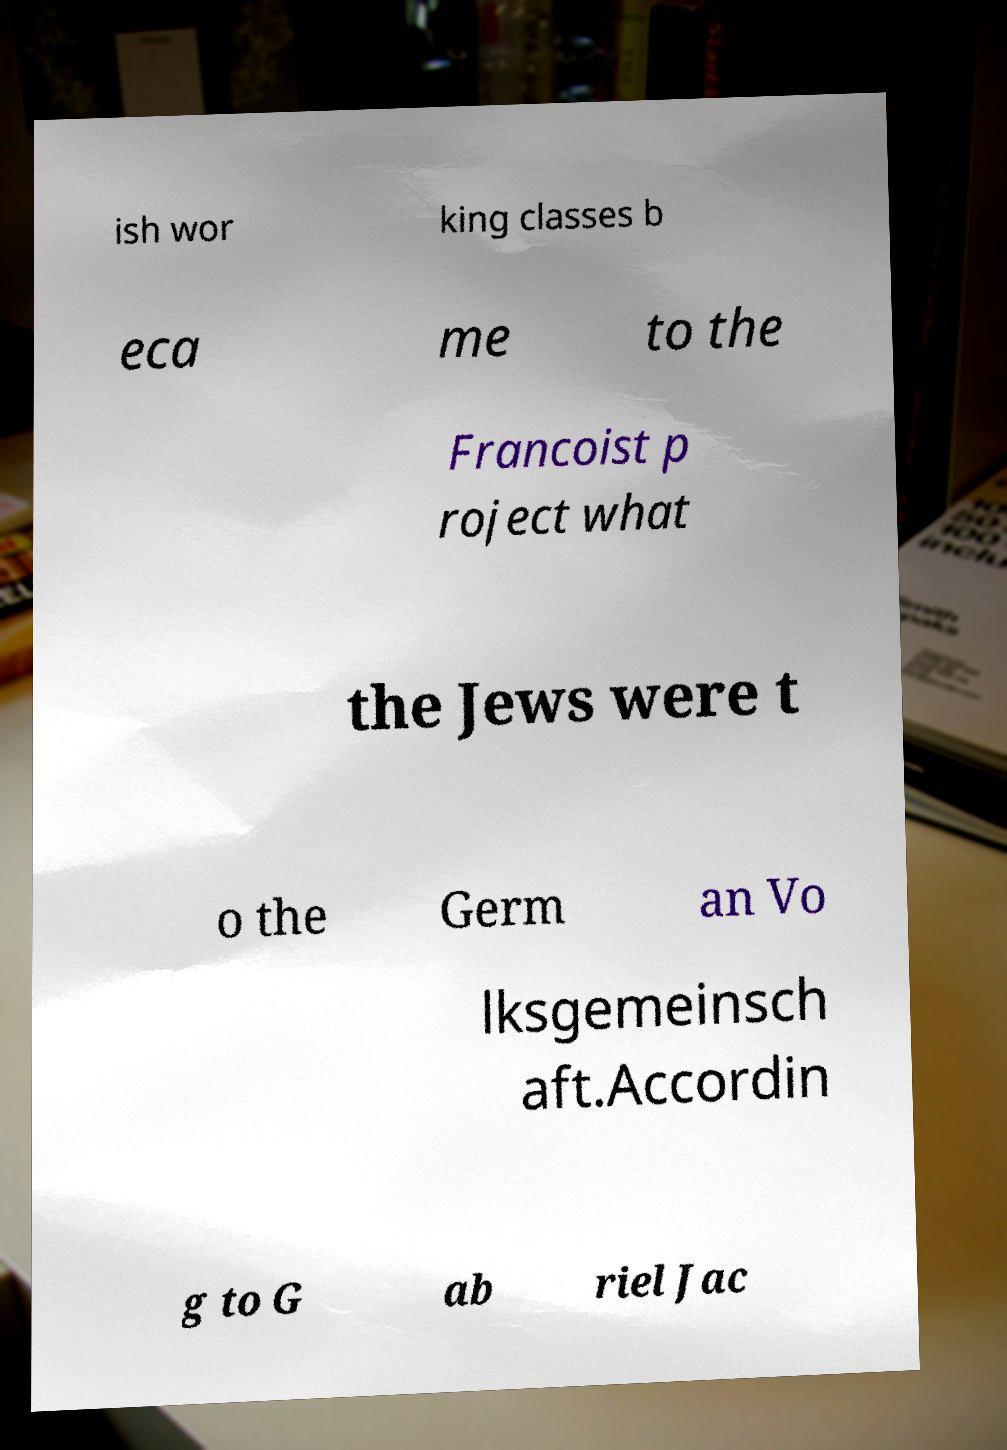Could you assist in decoding the text presented in this image and type it out clearly? ish wor king classes b eca me to the Francoist p roject what the Jews were t o the Germ an Vo lksgemeinsch aft.Accordin g to G ab riel Jac 